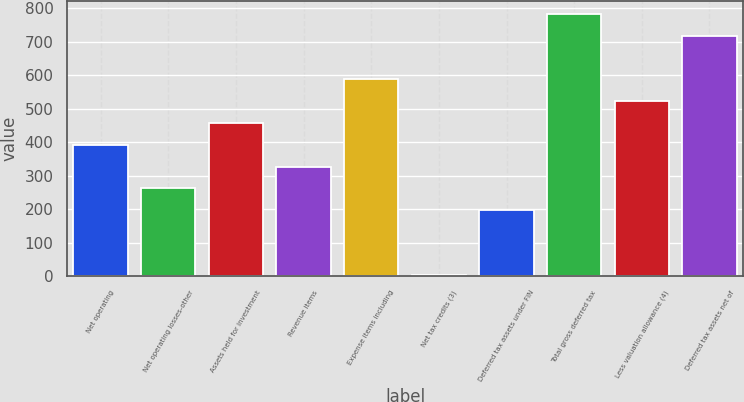<chart> <loc_0><loc_0><loc_500><loc_500><bar_chart><fcel>Net operating<fcel>Net operating losses-other<fcel>Assets held for investment<fcel>Revenue items<fcel>Expense items including<fcel>Net tax credits (3)<fcel>Deferred tax assets under FIN<fcel>Total gross deferred tax<fcel>Less valuation allowance (4)<fcel>Deferred tax assets net of<nl><fcel>392.6<fcel>262.4<fcel>457.7<fcel>327.5<fcel>587.9<fcel>2<fcel>197.3<fcel>783.2<fcel>522.8<fcel>718.1<nl></chart> 